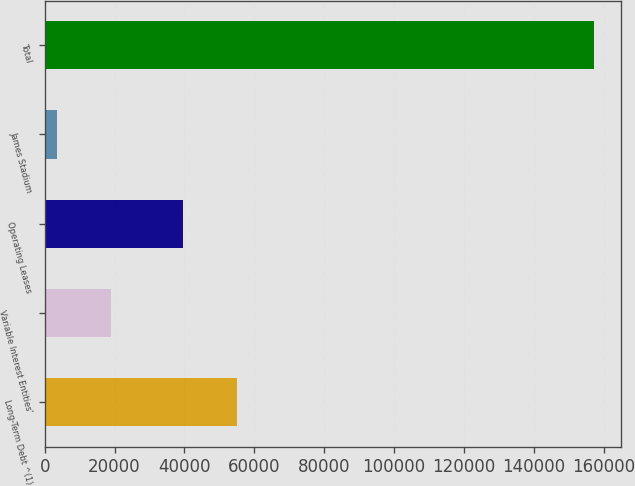<chart> <loc_0><loc_0><loc_500><loc_500><bar_chart><fcel>Long-Term Debt ^(1)<fcel>Variable Interest Entities'<fcel>Operating Leases<fcel>James Stadium<fcel>Total<nl><fcel>55043.6<fcel>18916.6<fcel>39672<fcel>3545<fcel>157261<nl></chart> 